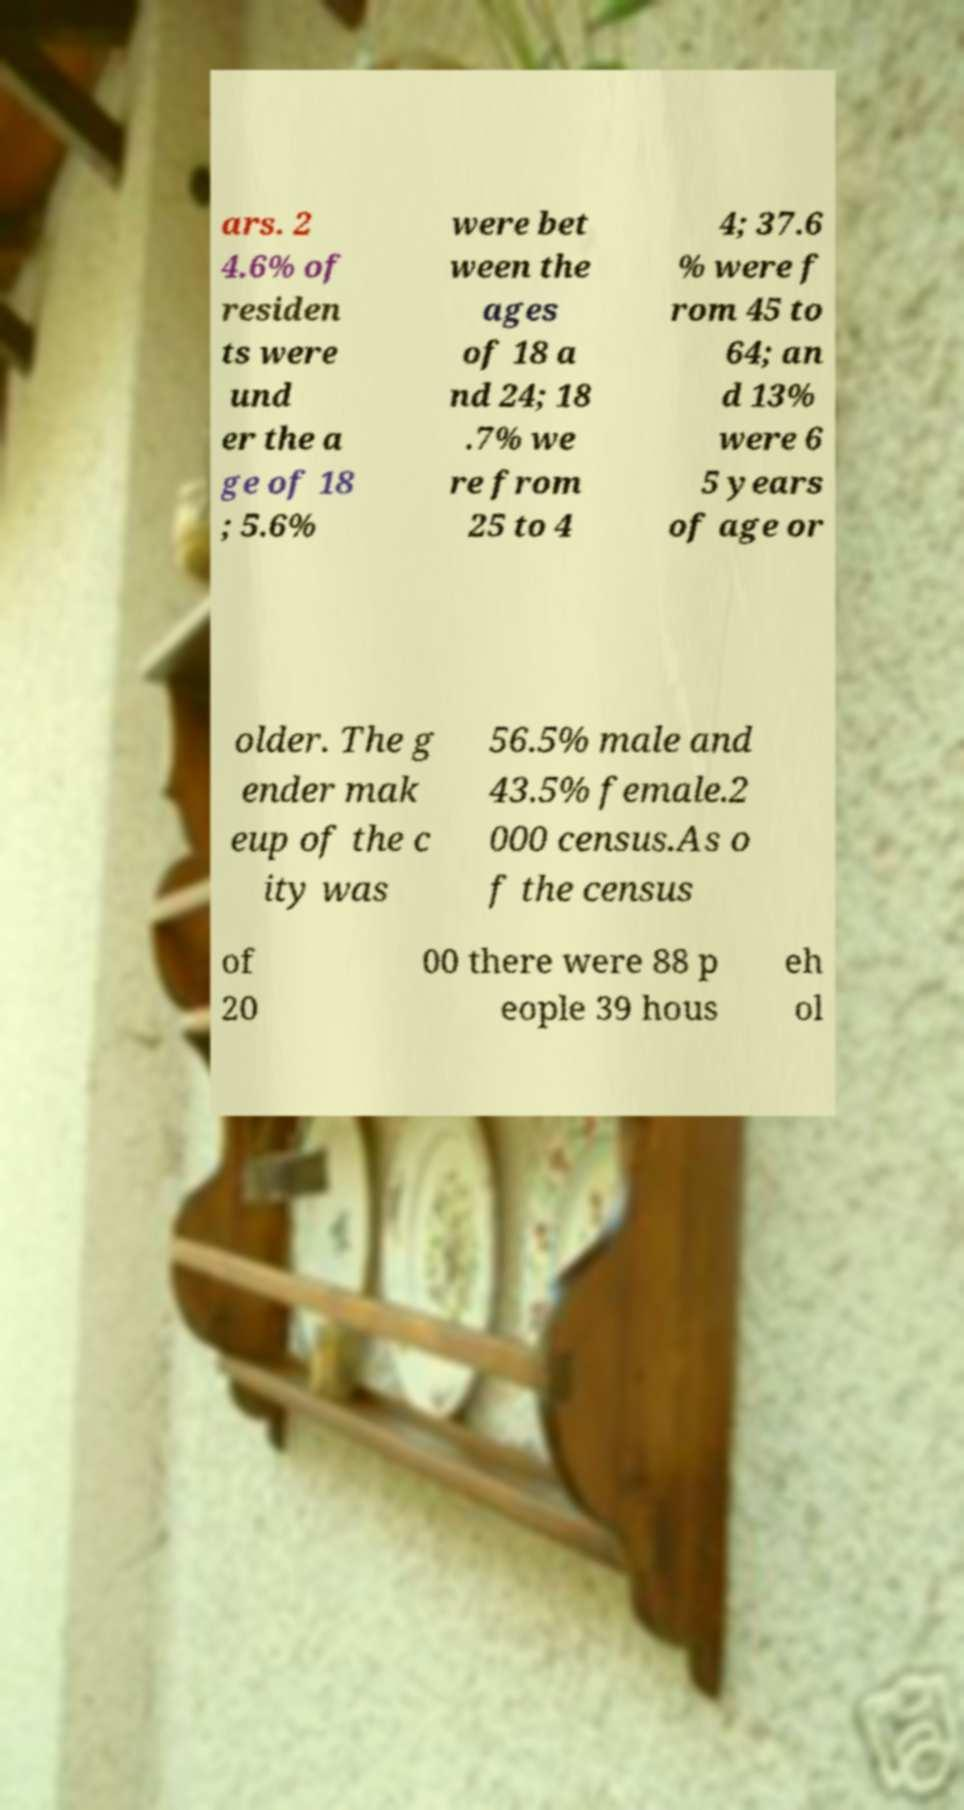What messages or text are displayed in this image? I need them in a readable, typed format. ars. 2 4.6% of residen ts were und er the a ge of 18 ; 5.6% were bet ween the ages of 18 a nd 24; 18 .7% we re from 25 to 4 4; 37.6 % were f rom 45 to 64; an d 13% were 6 5 years of age or older. The g ender mak eup of the c ity was 56.5% male and 43.5% female.2 000 census.As o f the census of 20 00 there were 88 p eople 39 hous eh ol 